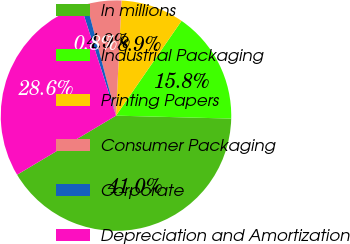Convert chart to OTSL. <chart><loc_0><loc_0><loc_500><loc_500><pie_chart><fcel>In millions<fcel>Industrial Packaging<fcel>Printing Papers<fcel>Consumer Packaging<fcel>Corporate<fcel>Depreciation and Amortization<nl><fcel>41.02%<fcel>15.78%<fcel>8.87%<fcel>4.85%<fcel>0.84%<fcel>28.64%<nl></chart> 